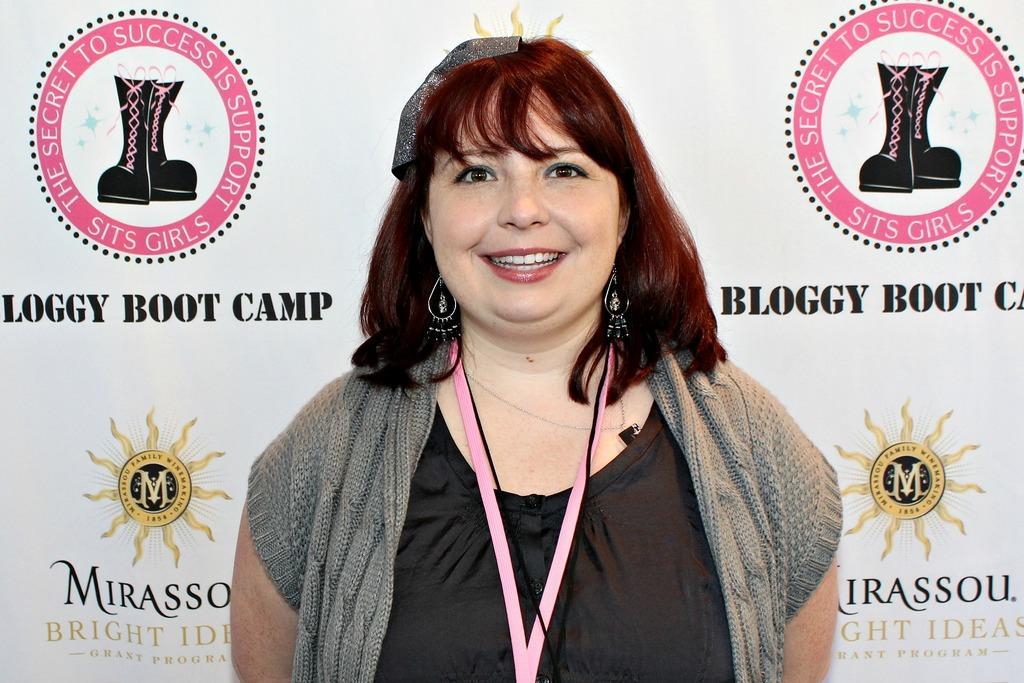Please provide a concise description of this image. In this picture I can see a woman standing and smiling, and in the background there is a board. 